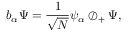<formula> <loc_0><loc_0><loc_500><loc_500>b _ { \alpha } \Psi = { \frac { 1 } { \sqrt { N } } } \psi _ { \alpha } \oslash _ { + } \Psi ,</formula> 